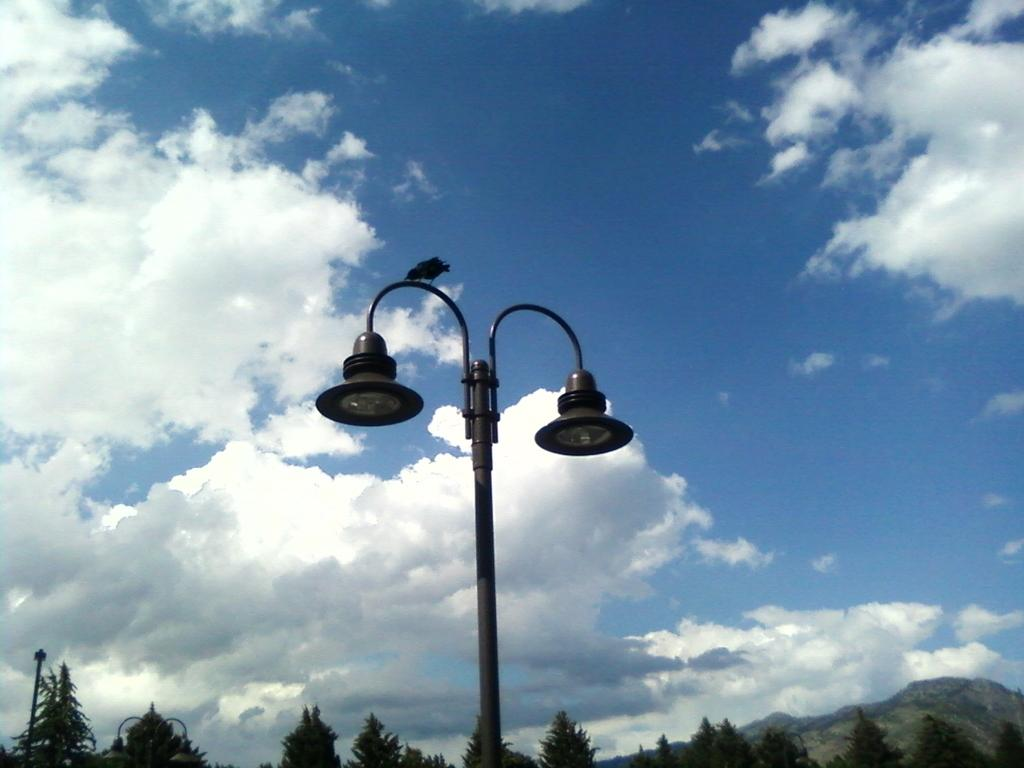What is located at the bottom of the picture? There are trees, a hill, and a street light at the bottom of the picture. What can be seen in the center of the picture? There is a street light and a bird in the center of the picture. What is the condition of the sky in the image? The sky is cloudy in the image. What type of ground does the bird claim as its territory in the image? There is no indication in the image that the bird is claiming any territory, and the concept of territory is not applicable to birds in this context. How does the bird roll down the hill in the image? The bird is not rolling down the hill in the image; it is perched in the center of the picture. 